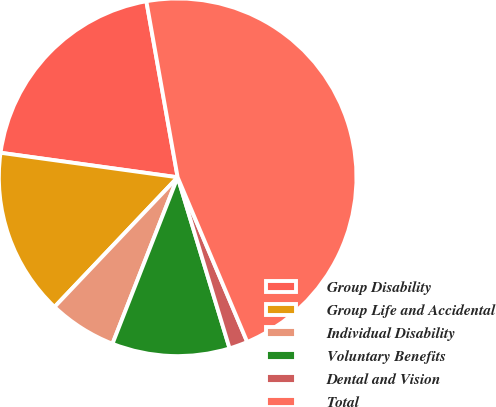<chart> <loc_0><loc_0><loc_500><loc_500><pie_chart><fcel>Group Disability<fcel>Group Life and Accidental<fcel>Individual Disability<fcel>Voluntary Benefits<fcel>Dental and Vision<fcel>Total<nl><fcel>20.01%<fcel>15.1%<fcel>6.15%<fcel>10.63%<fcel>1.67%<fcel>46.44%<nl></chart> 